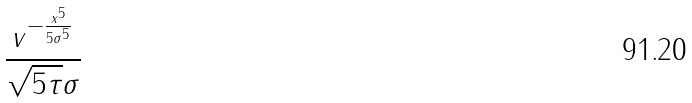<formula> <loc_0><loc_0><loc_500><loc_500>\frac { v ^ { - \frac { x ^ { 5 } } { 5 \sigma ^ { 5 } } } } { \sqrt { 5 \tau } \sigma }</formula> 